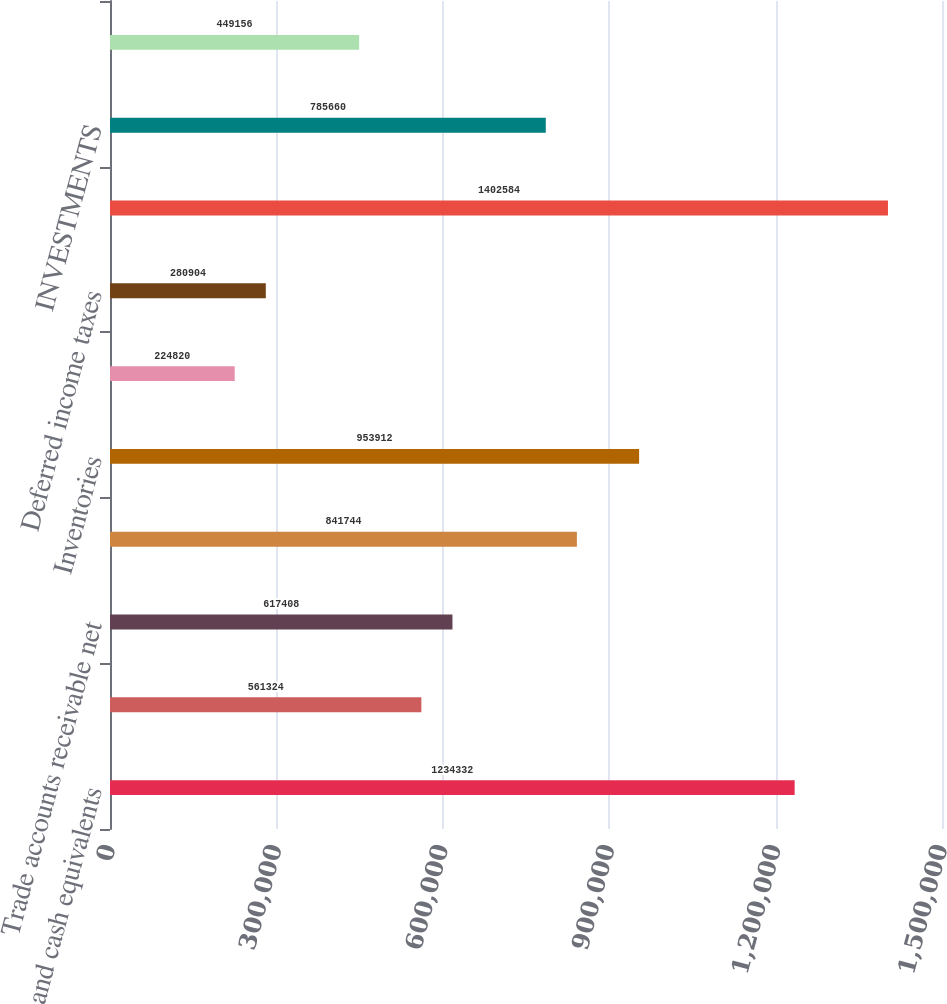<chart> <loc_0><loc_0><loc_500><loc_500><bar_chart><fcel>Cash and cash equivalents<fcel>Short-term investments<fcel>Trade accounts receivable net<fcel>Distributor receivables<fcel>Inventories<fcel>Prepaid expenses and other<fcel>Deferred income taxes<fcel>Total current assets<fcel>INVESTMENTS<fcel>PROPERTY AND EQUIPMENT net<nl><fcel>1.23433e+06<fcel>561324<fcel>617408<fcel>841744<fcel>953912<fcel>224820<fcel>280904<fcel>1.40258e+06<fcel>785660<fcel>449156<nl></chart> 